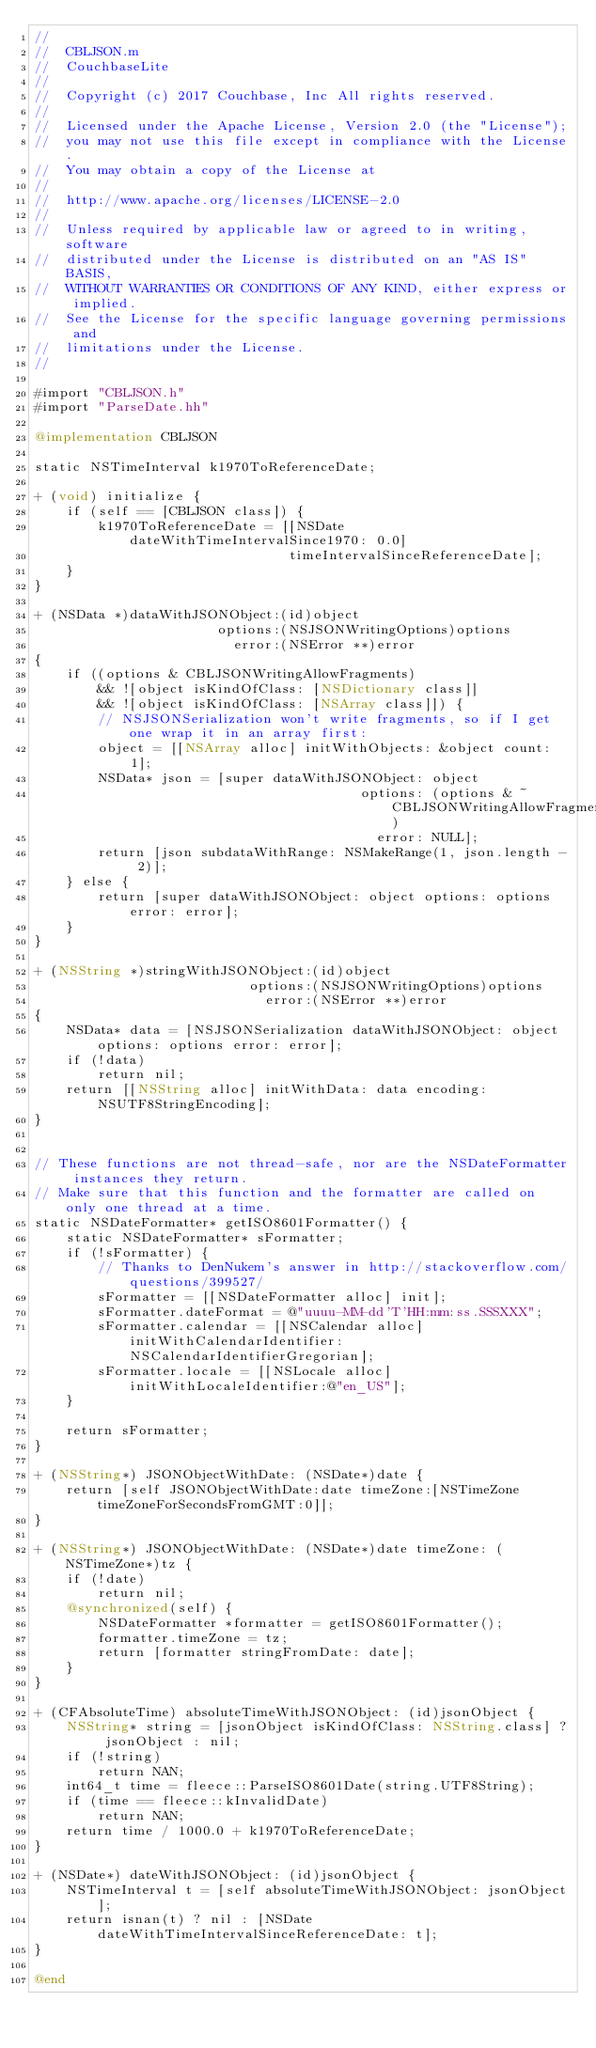<code> <loc_0><loc_0><loc_500><loc_500><_ObjectiveC_>//
//  CBLJSON.m
//  CouchbaseLite
//
//  Copyright (c) 2017 Couchbase, Inc All rights reserved.
//
//  Licensed under the Apache License, Version 2.0 (the "License");
//  you may not use this file except in compliance with the License.
//  You may obtain a copy of the License at
//
//  http://www.apache.org/licenses/LICENSE-2.0
//
//  Unless required by applicable law or agreed to in writing, software
//  distributed under the License is distributed on an "AS IS" BASIS,
//  WITHOUT WARRANTIES OR CONDITIONS OF ANY KIND, either express or implied.
//  See the License for the specific language governing permissions and
//  limitations under the License.
//

#import "CBLJSON.h"
#import "ParseDate.hh"

@implementation CBLJSON

static NSTimeInterval k1970ToReferenceDate;

+ (void) initialize {
    if (self == [CBLJSON class]) {
        k1970ToReferenceDate = [[NSDate dateWithTimeIntervalSince1970: 0.0]
                                timeIntervalSinceReferenceDate];
    }
}

+ (NSData *)dataWithJSONObject:(id)object
                       options:(NSJSONWritingOptions)options
                         error:(NSError **)error
{
    if ((options & CBLJSONWritingAllowFragments)
        && ![object isKindOfClass: [NSDictionary class]]
        && ![object isKindOfClass: [NSArray class]]) {
        // NSJSONSerialization won't write fragments, so if I get one wrap it in an array first:
        object = [[NSArray alloc] initWithObjects: &object count: 1];
        NSData* json = [super dataWithJSONObject: object
                                         options: (options & ~CBLJSONWritingAllowFragments)
                                           error: NULL];
        return [json subdataWithRange: NSMakeRange(1, json.length - 2)];
    } else {
        return [super dataWithJSONObject: object options: options error: error];
    }
}

+ (NSString *)stringWithJSONObject:(id)object
                           options:(NSJSONWritingOptions)options
                             error:(NSError **)error
{
    NSData* data = [NSJSONSerialization dataWithJSONObject: object options: options error: error];
    if (!data)
        return nil;
    return [[NSString alloc] initWithData: data encoding: NSUTF8StringEncoding];
}


// These functions are not thread-safe, nor are the NSDateFormatter instances they return.
// Make sure that this function and the formatter are called on only one thread at a time.
static NSDateFormatter* getISO8601Formatter() {
    static NSDateFormatter* sFormatter;
    if (!sFormatter) {
        // Thanks to DenNukem's answer in http://stackoverflow.com/questions/399527/
        sFormatter = [[NSDateFormatter alloc] init];
        sFormatter.dateFormat = @"uuuu-MM-dd'T'HH:mm:ss.SSSXXX";
        sFormatter.calendar = [[NSCalendar alloc] initWithCalendarIdentifier:NSCalendarIdentifierGregorian];
        sFormatter.locale = [[NSLocale alloc] initWithLocaleIdentifier:@"en_US"];
    }
    
    return sFormatter;
}

+ (NSString*) JSONObjectWithDate: (NSDate*)date {
    return [self JSONObjectWithDate:date timeZone:[NSTimeZone timeZoneForSecondsFromGMT:0]];
}

+ (NSString*) JSONObjectWithDate: (NSDate*)date timeZone: (NSTimeZone*)tz {
    if (!date)
        return nil;
    @synchronized(self) {
        NSDateFormatter *formatter = getISO8601Formatter();
        formatter.timeZone = tz;
        return [formatter stringFromDate: date];
    }
}

+ (CFAbsoluteTime) absoluteTimeWithJSONObject: (id)jsonObject {
    NSString* string = [jsonObject isKindOfClass: NSString.class] ? jsonObject : nil;
    if (!string)
        return NAN;
    int64_t time = fleece::ParseISO8601Date(string.UTF8String);
    if (time == fleece::kInvalidDate)
        return NAN;
    return time / 1000.0 + k1970ToReferenceDate;
}

+ (NSDate*) dateWithJSONObject: (id)jsonObject {
    NSTimeInterval t = [self absoluteTimeWithJSONObject: jsonObject];
    return isnan(t) ? nil : [NSDate dateWithTimeIntervalSinceReferenceDate: t];
}

@end
</code> 